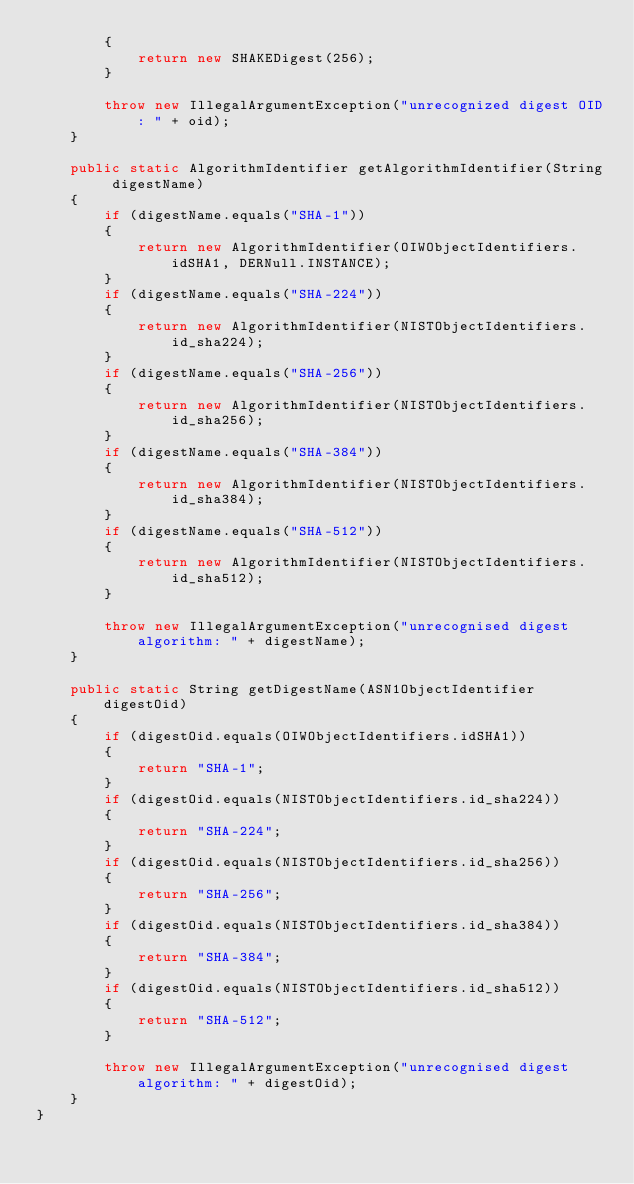Convert code to text. <code><loc_0><loc_0><loc_500><loc_500><_Java_>        {
            return new SHAKEDigest(256);
        }

        throw new IllegalArgumentException("unrecognized digest OID: " + oid);
    }

    public static AlgorithmIdentifier getAlgorithmIdentifier(String digestName)
    {
        if (digestName.equals("SHA-1"))
        {
            return new AlgorithmIdentifier(OIWObjectIdentifiers.idSHA1, DERNull.INSTANCE);
        }
        if (digestName.equals("SHA-224"))
        {
            return new AlgorithmIdentifier(NISTObjectIdentifiers.id_sha224);
        }
        if (digestName.equals("SHA-256"))
        {
            return new AlgorithmIdentifier(NISTObjectIdentifiers.id_sha256);
        }
        if (digestName.equals("SHA-384"))
        {
            return new AlgorithmIdentifier(NISTObjectIdentifiers.id_sha384);
        }
        if (digestName.equals("SHA-512"))
        {
            return new AlgorithmIdentifier(NISTObjectIdentifiers.id_sha512);
        }

        throw new IllegalArgumentException("unrecognised digest algorithm: " + digestName);
    }

    public static String getDigestName(ASN1ObjectIdentifier digestOid)
    {
        if (digestOid.equals(OIWObjectIdentifiers.idSHA1))
        {
            return "SHA-1";
        }
        if (digestOid.equals(NISTObjectIdentifiers.id_sha224))
        {
            return "SHA-224";
        }
        if (digestOid.equals(NISTObjectIdentifiers.id_sha256))
        {
            return "SHA-256";
        }
        if (digestOid.equals(NISTObjectIdentifiers.id_sha384))
        {
            return "SHA-384";
        }
        if (digestOid.equals(NISTObjectIdentifiers.id_sha512))
        {
            return "SHA-512";
        }

        throw new IllegalArgumentException("unrecognised digest algorithm: " + digestOid);
    }
}
</code> 